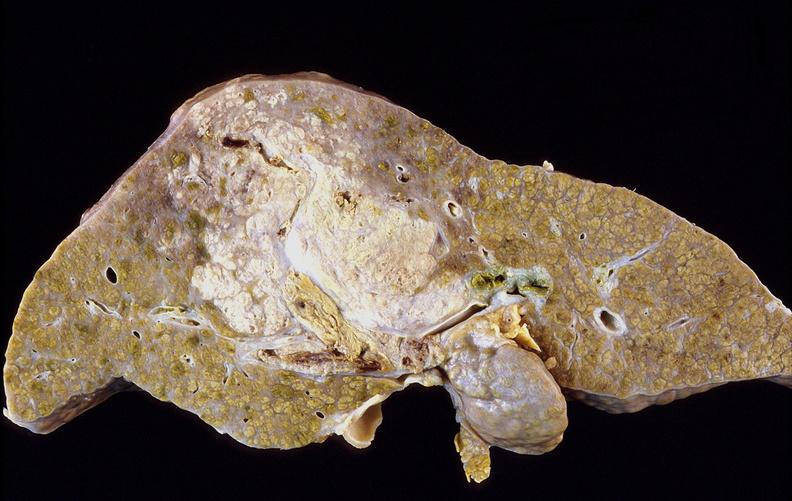what is present?
Answer the question using a single word or phrase. Liver 